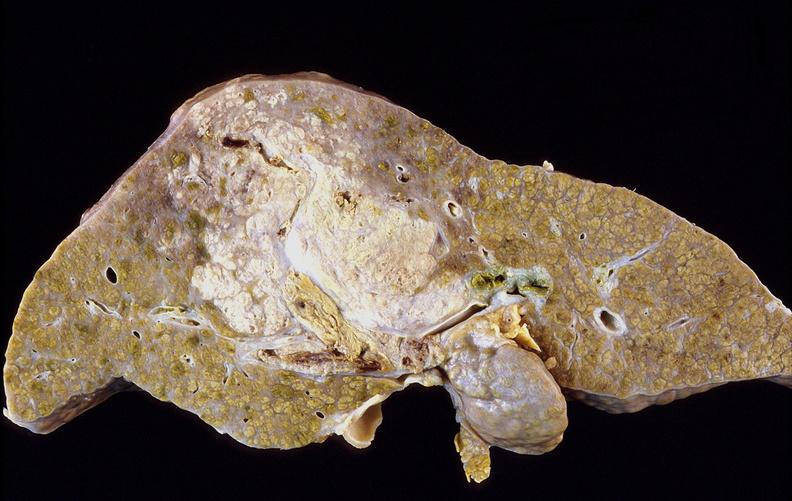what is present?
Answer the question using a single word or phrase. Liver 